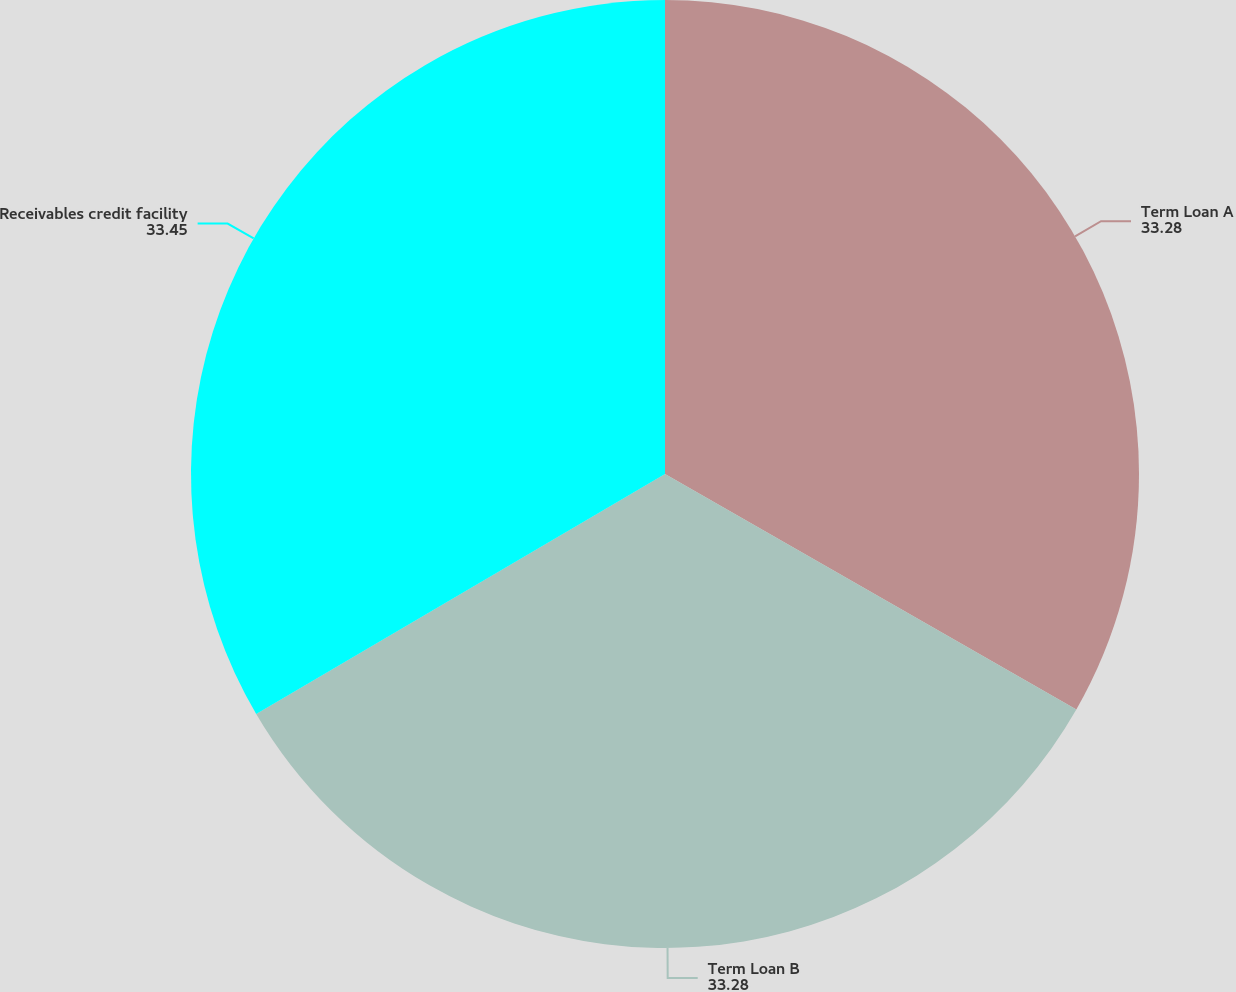Convert chart to OTSL. <chart><loc_0><loc_0><loc_500><loc_500><pie_chart><fcel>Term Loan A<fcel>Term Loan B<fcel>Receivables credit facility<nl><fcel>33.28%<fcel>33.28%<fcel>33.45%<nl></chart> 